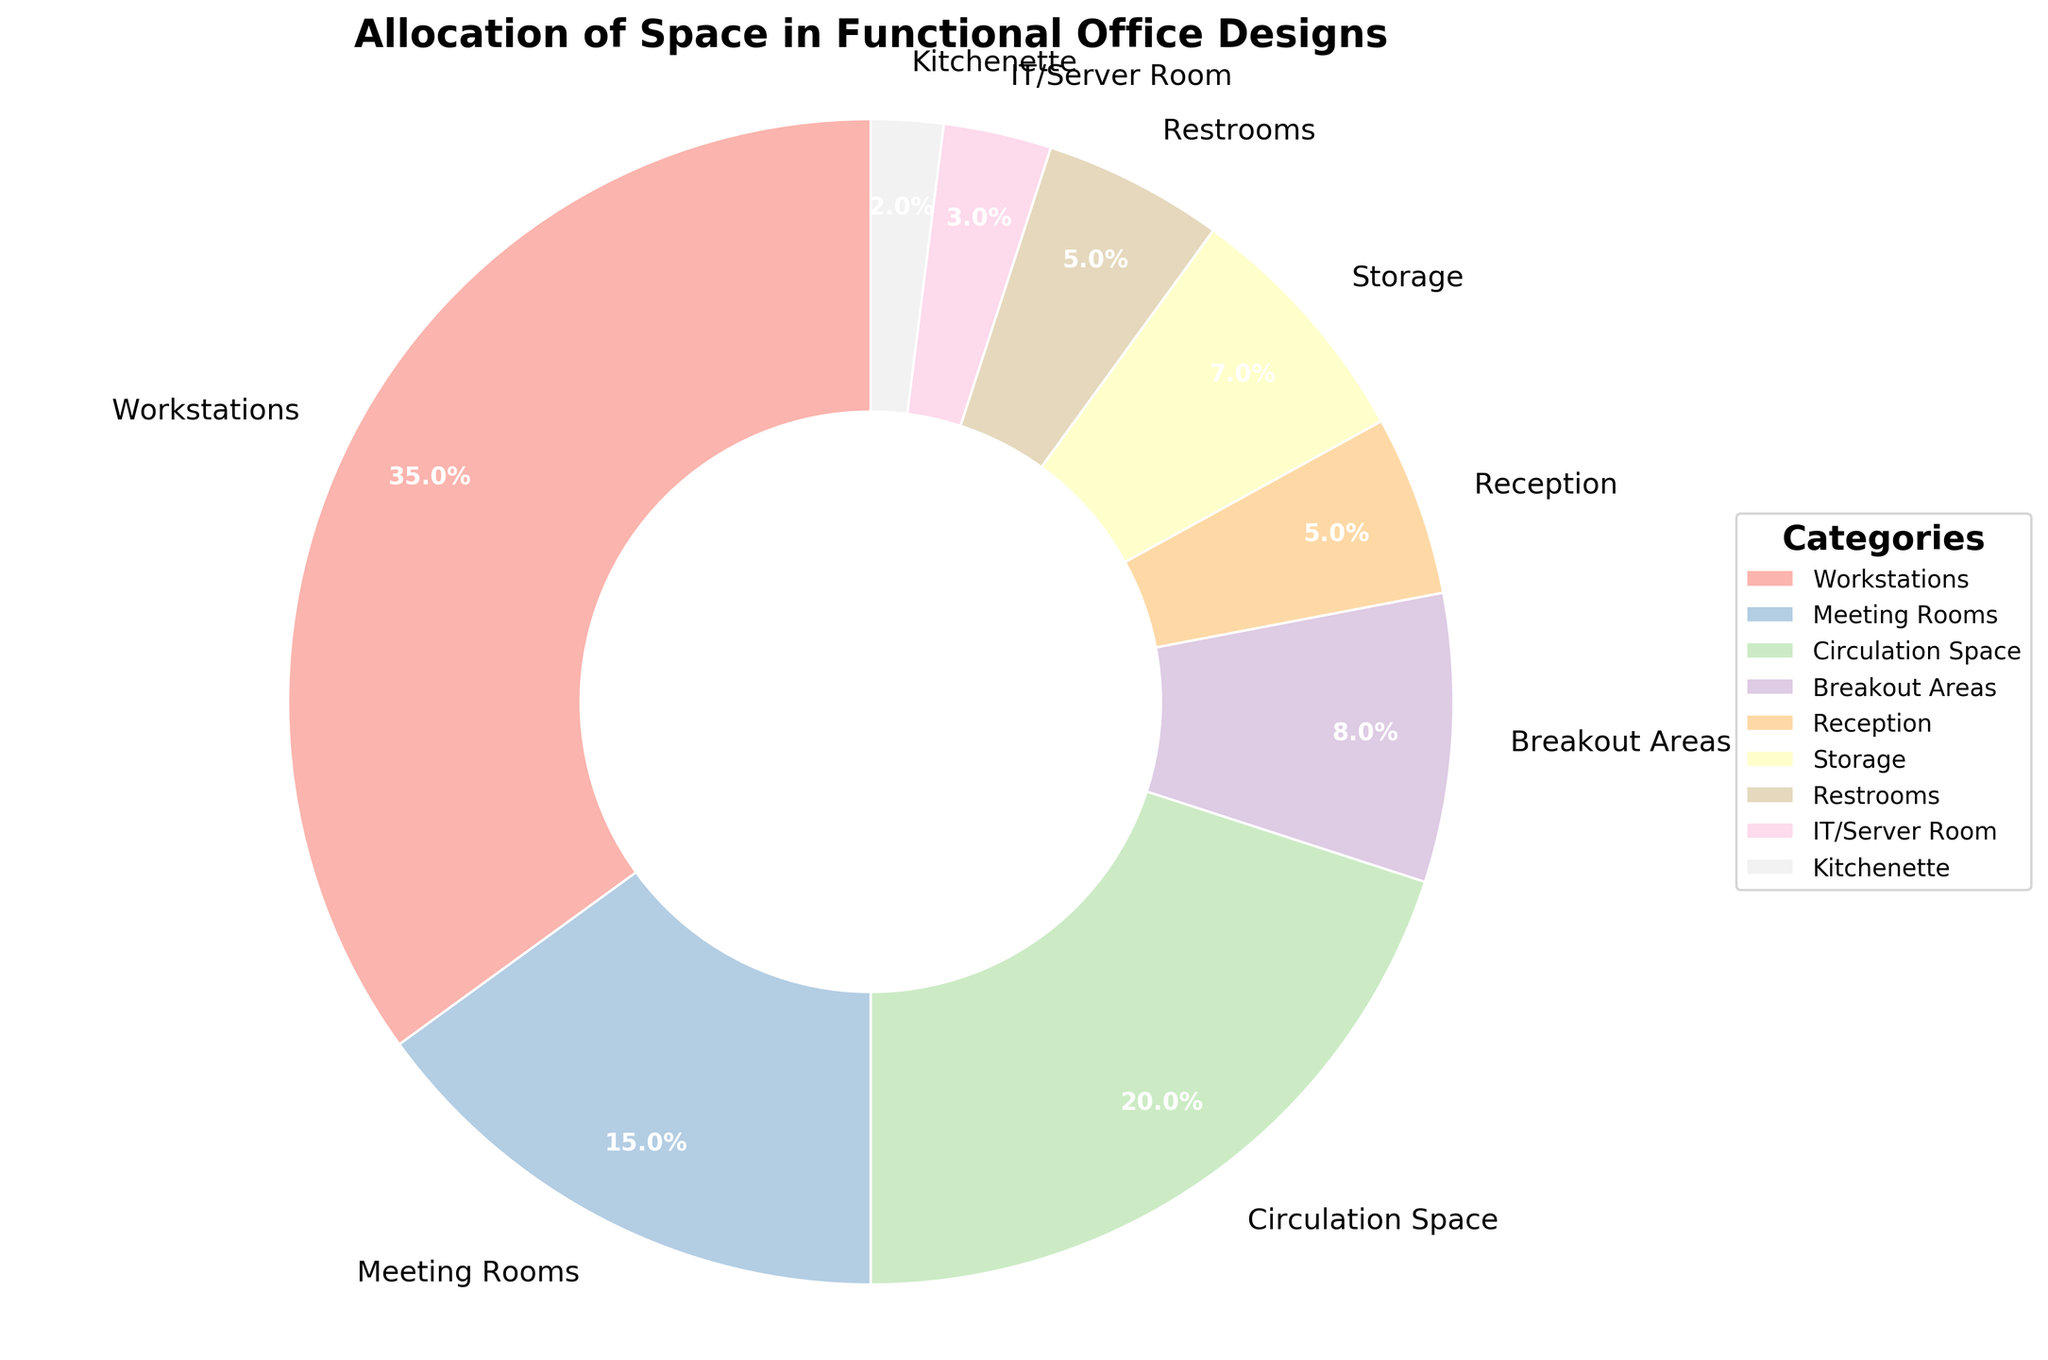what percentage of space is allocated to breakout areas and the kitchenette combined? Add the percentages of Breakout Areas (8%) and Kitchenette (2%). 8% + 2% = 10%
Answer: 10% which category occupies more space: meeting rooms or storage? Compare the allocated space for Meeting Rooms (15%) and Storage (7%). Since 15% > 7%, Meeting Rooms occupy more
Answer: Meeting Rooms what visual feature indicates the proportion of each category in the chart? The size of each pie wedge represents the proportion of each category. Larger wedges indicate higher percentages
Answer: the size of pie wedges how much more space is given to workstations compared to IT/server rooms? Subtract the percentage allocated to IT/Server Room (3%) from Workstations (35%). 35% - 3% = 32%
Answer: 32% are the spaces allocated to circulation spaces and restrooms equal or different? Compare the percentages for Circulation Space (20%) and Restrooms (5%). Since 20% ≠ 5%, they are different
Answer: different which two categories combined have the same allocated space as workstations? Identify categories where the sum of percentages equals Workstations (35%). Breakout Areas (8%) + Circulation Space (20%) + Kitchenette (2%) + IT/Server Room (3%) = 33% does not match. Breakout Areas (8%) + Meeting Rooms (15%) + Storage (7%) + Restrooms (5%) = 35% matches
Answer: Breakout Areas and Meeting Rooms and Storage and Restrooms which category occupies the smallest portion of space in the office design? Identify the slice with the smallest percentage. Kitchenette with 2% is the smallest
Answer: Kitchenette what is the cumulative percentage of space for meeting rooms, reception, and storage? Add the percentages for Meeting Rooms (15%), Reception (5%), and Storage (7%). 15% + 5% + 7% = 27%
Answer: 27% how does the visual representation differentiate between workstations and breakout areas? The wedge for Workstations (35%) is larger compared to that of Breakout Areas (8%), showing more space allocated to Workstations
Answer: wedge size which categories have an equal allocation of space? Identify categories with the same percentage. Reception (5%) and Restrooms (5%) both have equal allocation
Answer: Reception and Restrooms 